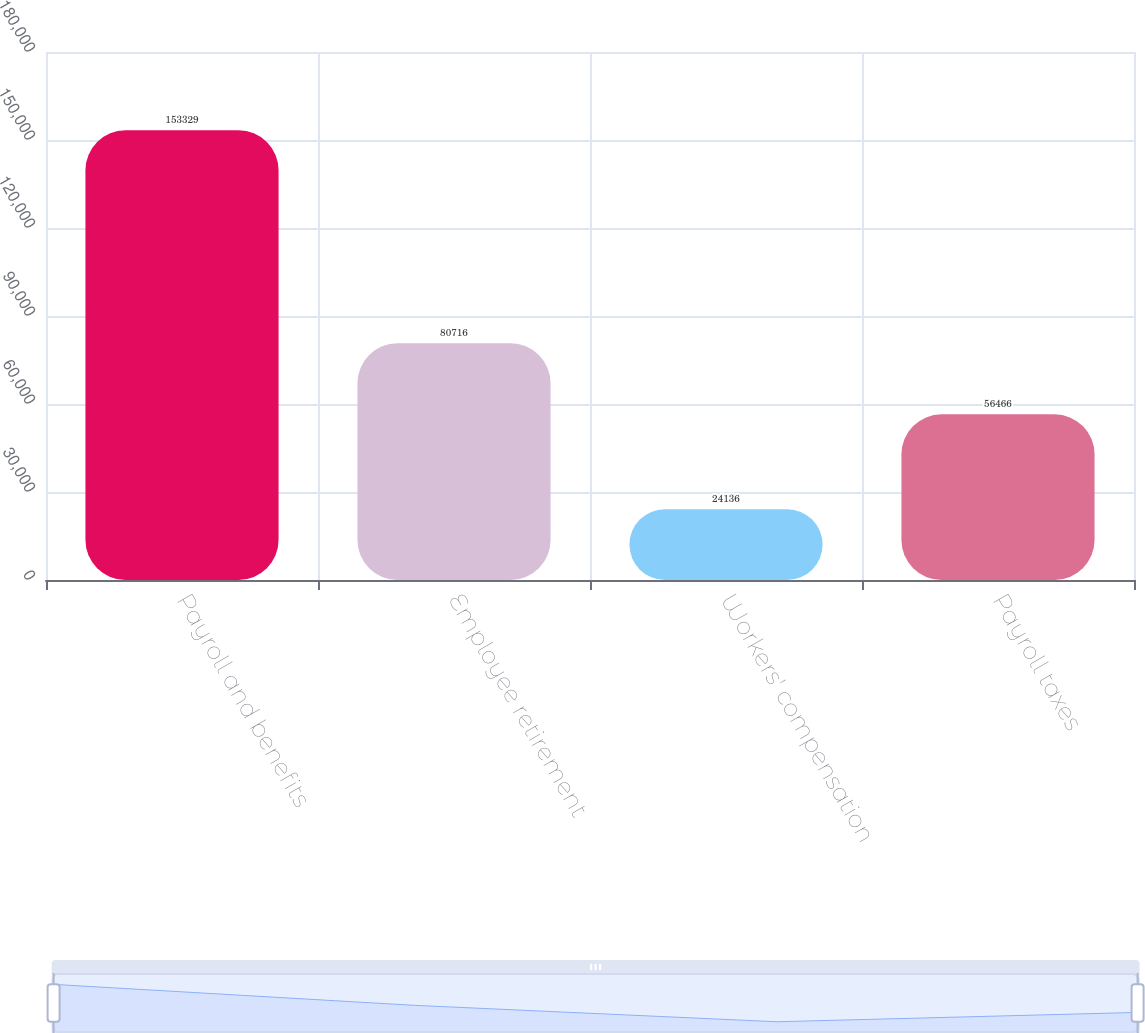Convert chart. <chart><loc_0><loc_0><loc_500><loc_500><bar_chart><fcel>Payroll and benefits<fcel>Employee retirement<fcel>Workers' compensation<fcel>Payroll taxes<nl><fcel>153329<fcel>80716<fcel>24136<fcel>56466<nl></chart> 